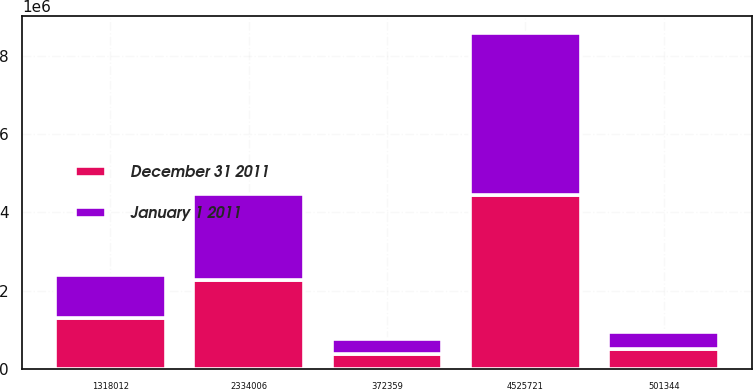Convert chart to OTSL. <chart><loc_0><loc_0><loc_500><loc_500><stacked_bar_chart><ecel><fcel>2334006<fcel>1318012<fcel>372359<fcel>501344<fcel>4525721<nl><fcel>December 31 2011<fcel>2.26117e+06<fcel>1.28931e+06<fcel>375440<fcel>508372<fcel>4.43429e+06<nl><fcel>January 1 2011<fcel>2.21403e+06<fcel>1.11137e+06<fcel>377847<fcel>442763<fcel>4.14601e+06<nl></chart> 